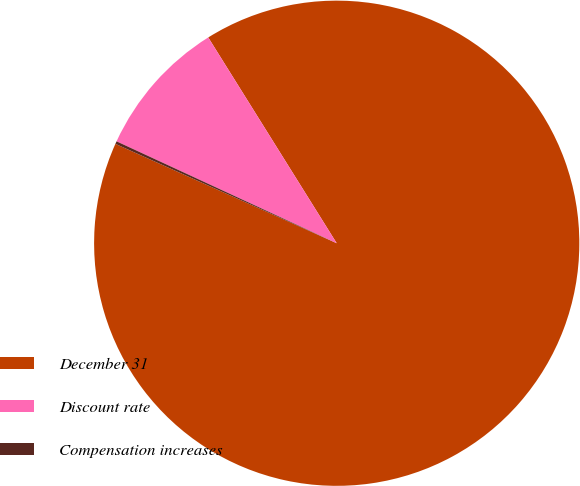Convert chart. <chart><loc_0><loc_0><loc_500><loc_500><pie_chart><fcel>December 31<fcel>Discount rate<fcel>Compensation increases<nl><fcel>90.6%<fcel>9.22%<fcel>0.18%<nl></chart> 